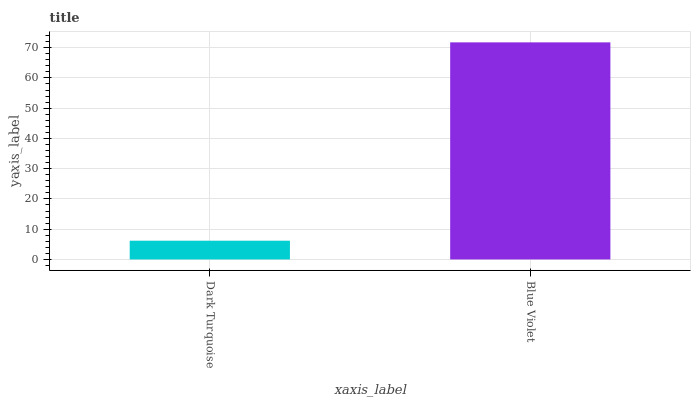Is Dark Turquoise the minimum?
Answer yes or no. Yes. Is Blue Violet the maximum?
Answer yes or no. Yes. Is Blue Violet the minimum?
Answer yes or no. No. Is Blue Violet greater than Dark Turquoise?
Answer yes or no. Yes. Is Dark Turquoise less than Blue Violet?
Answer yes or no. Yes. Is Dark Turquoise greater than Blue Violet?
Answer yes or no. No. Is Blue Violet less than Dark Turquoise?
Answer yes or no. No. Is Blue Violet the high median?
Answer yes or no. Yes. Is Dark Turquoise the low median?
Answer yes or no. Yes. Is Dark Turquoise the high median?
Answer yes or no. No. Is Blue Violet the low median?
Answer yes or no. No. 